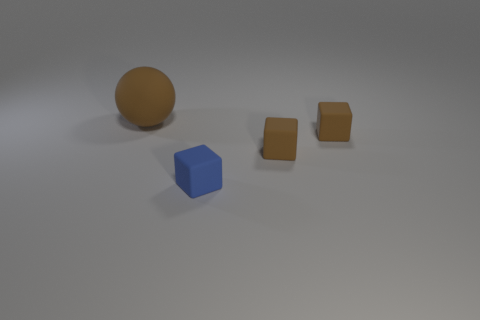What number of other things are there of the same color as the large object?
Give a very brief answer. 2. How many objects are small yellow metal blocks or small blue rubber cubes?
Offer a terse response. 1. There is a matte thing that is left of the small blue rubber thing; what is its color?
Your answer should be very brief. Brown. Is the number of small rubber objects behind the rubber ball less than the number of tiny brown objects?
Your answer should be very brief. Yes. Are there any other things that are the same size as the blue matte block?
Provide a succinct answer. Yes. Is the material of the big thing the same as the blue cube?
Your answer should be compact. Yes. How many objects are either blue things that are in front of the big brown matte ball or rubber blocks behind the small blue matte object?
Keep it short and to the point. 3. Is there a blue rubber cube that has the same size as the brown matte ball?
Ensure brevity in your answer.  No. Are there any big brown rubber balls that are in front of the brown thing that is left of the blue matte cube?
Your response must be concise. No. Is the shape of the brown object that is to the left of the blue thing the same as  the tiny blue thing?
Offer a very short reply. No. 